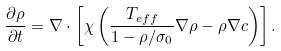<formula> <loc_0><loc_0><loc_500><loc_500>\frac { \partial \rho } { \partial t } = \nabla \cdot \left [ \chi \left ( \frac { T _ { e f f } } { 1 - \rho / \sigma _ { 0 } } \nabla \rho - \rho \nabla c \right ) \right ] .</formula> 